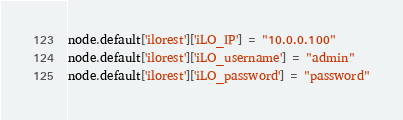<code> <loc_0><loc_0><loc_500><loc_500><_Ruby_>node.default['ilorest']['iLO_IP'] = "10.0.0.100"
node.default['ilorest']['iLO_username'] = "admin"
node.default['ilorest']['iLO_password'] = "password"
</code> 